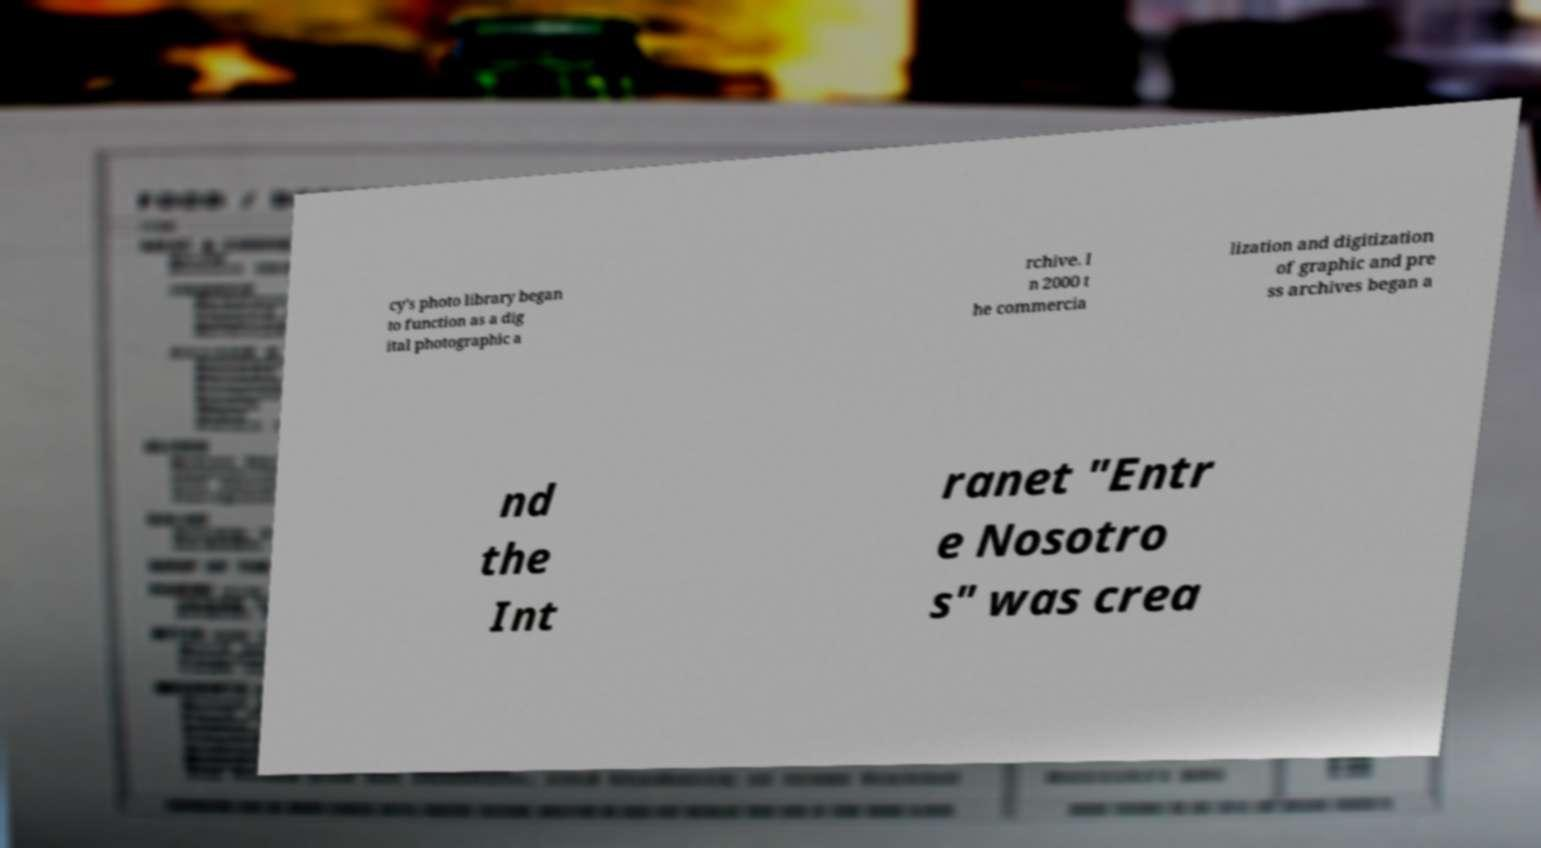Can you read and provide the text displayed in the image?This photo seems to have some interesting text. Can you extract and type it out for me? cy's photo library began to function as a dig ital photographic a rchive. I n 2000 t he commercia lization and digitization of graphic and pre ss archives began a nd the Int ranet "Entr e Nosotro s" was crea 